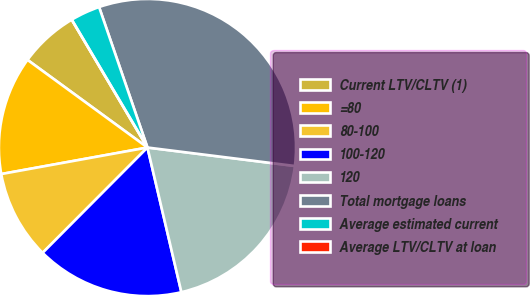<chart> <loc_0><loc_0><loc_500><loc_500><pie_chart><fcel>Current LTV/CLTV (1)<fcel>=80<fcel>80-100<fcel>100-120<fcel>120<fcel>Total mortgage loans<fcel>Average estimated current<fcel>Average LTV/CLTV at loan<nl><fcel>6.45%<fcel>12.9%<fcel>9.68%<fcel>16.13%<fcel>19.35%<fcel>32.26%<fcel>3.23%<fcel>0.0%<nl></chart> 